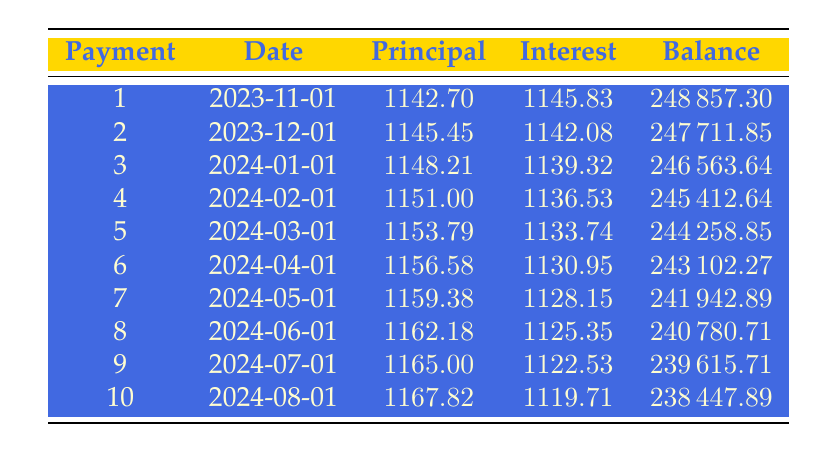What is the total loan amount for the gallery? The total loan amount specified in the data is directly mentioned as 250,000.
Answer: 250000 What was the monthly payment amount for the loan? The monthly payment amount is listed in the data as 2,654.70.
Answer: 2654.70 How much was paid towards the principal in the first payment? The principal payment for the first payment is directly stated as 1,142.70.
Answer: 1142.70 What is the total interest paid in the first 3 payments? The interest paid in the first payment is 1,145.83, the second is 1,142.08, and the third is 1,139.32. Adding these together gives: 1,145.83 + 1,142.08 + 1,139.32 = 3,427.23.
Answer: 3427.23 Is the interest payment in the first month higher than in the second month? The interest payment for the first month is 1,145.83, while the payment for the second month is 1,142.08. Since 1,145.83 > 1,142.08, it is true that the first month’s payment is higher.
Answer: Yes What is the remaining balance after the 5th payment? The remaining balance after the 5th payment is listed as 244,258.85, as stated in the data.
Answer: 244258.85 What is the difference between the principal payments of the first and the tenth payment? The principal payment for the first payment is 1,142.70 and for the tenth payment is 1,167.82. The difference is calculated as 1,167.82 - 1,142.70 = 25.12.
Answer: 25.12 What is the average principal payment over the first five months? The total principal payments over the first five months are: 1,142.70 + 1,145.45 + 1,148.21 + 1,151.00 + 1,153.79 = 5,740.15. To find the average, divide by 5, giving: 5,740.15 / 5 = 1,148.03.
Answer: 1148.03 After how many months will the remaining balance drop below 240,000? Looking at the table, the remaining balance drops below 240,000 after the 8th payment, which has a remaining balance of 240,780.71. The 9th payment shows a remaining balance of 239,615.71. Thus, after month 9, it is below 240,000.
Answer: 9 months 